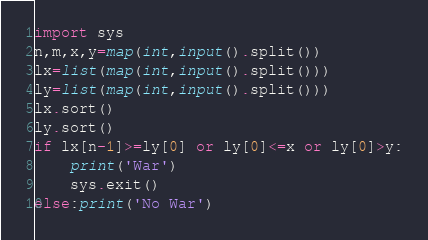Convert code to text. <code><loc_0><loc_0><loc_500><loc_500><_Python_>import sys
n,m,x,y=map(int,input().split())
lx=list(map(int,input().split()))
ly=list(map(int,input().split()))
lx.sort()
ly.sort()
if lx[n-1]>=ly[0] or ly[0]<=x or ly[0]>y:
    print('War')
    sys.exit()
else:print('No War')</code> 